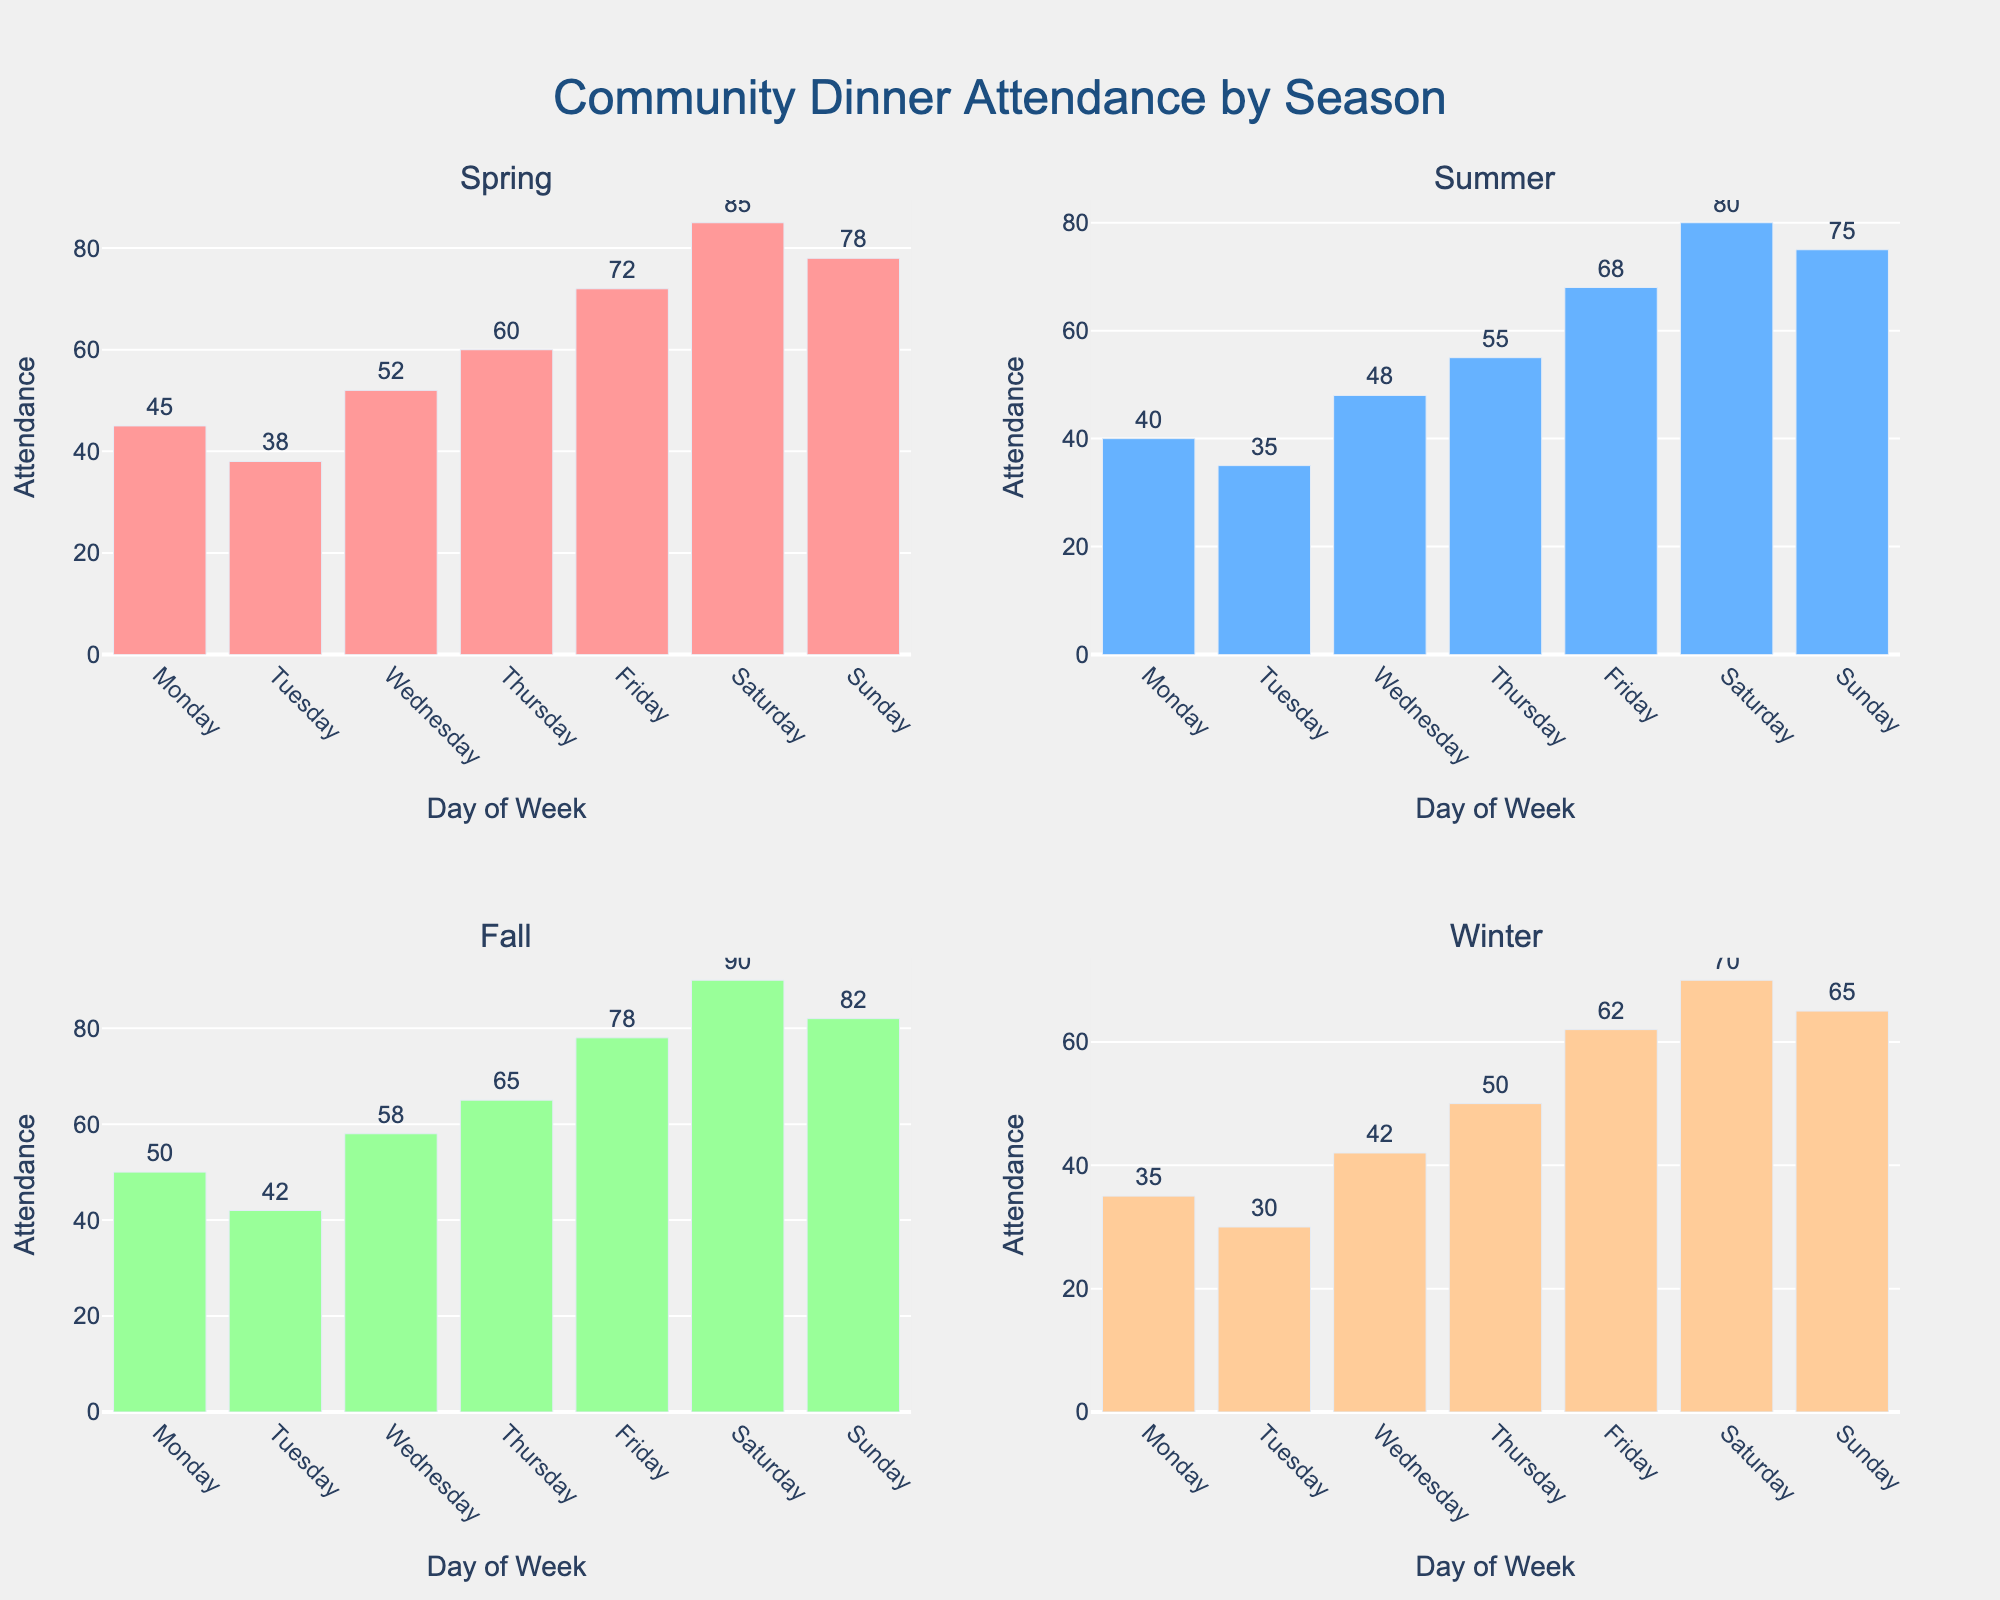Which season has the highest attendance on Fridays? Look at the bars corresponding to Fridays in each season subplot and compare the heights. The Fall season has the highest attendance on Fridays.
Answer: Fall What's the total attendance for all Sundays across the seasons? Sum the attendance values for all Sundays: Spring (78) + Summer (75) + Fall (82) + Winter (65). Summing these values gives 78 + 75 + 82 + 65 = 300.
Answer: 300 Which day of the week shows the highest attendance in Winter? Compare the heights of all the bars in the Winter subplot. Saturday has the highest attendance in Winter.
Answer: Saturday What's the average attendance rate for all the days in Summer? Sum the attendance rates for all days in Summer and divide by 7. (40 + 35 + 48 + 55 + 68 + 80 + 75) / 7 = 401 / 7 ≈ 57.29.
Answer: 57.29 How does the attendance on Wednesdays in Spring compare to Wednesdays in Fall? Compare the heights of the Wednesday bars in the Spring and Fall subplots. Spring has an attendance of 52, and Fall has 58; so Fall has higher attendance.
Answer: Fall What is the difference in attendance between the highest attended day and the lowest attended day in Winter? Identify the highest (Saturday, 70) and lowest (Tuesday, 30) attendance in Winter, then subtract the lowest from the highest. 70 - 30 = 40.
Answer: 40 Among the four seasons, which one has the least variance in attendance throughout the week? Observe the consistency of bar heights within each season. Winter bars are the most consistent (smallest variation).
Answer: Winter What is the average attendance on Fridays across all seasons? Sum the attendance on Fridays for all seasons and divide by 4. (72 + 68 + 78 + 62) / 4 = 280 / 4 = 70.
Answer: 70 Which season has the highest cumulative attendance for weekend days (Saturday and Sunday)? Sum the attendance for Saturday and Sunday in each season: 
- Spring: 85 + 78 = 163
- Summer: 80 + 75 = 155
- Fall: 90 + 82 = 172
- Winter: 70 + 65 = 135. 
Fall has the highest cumulative attendance.
Answer: Fall 